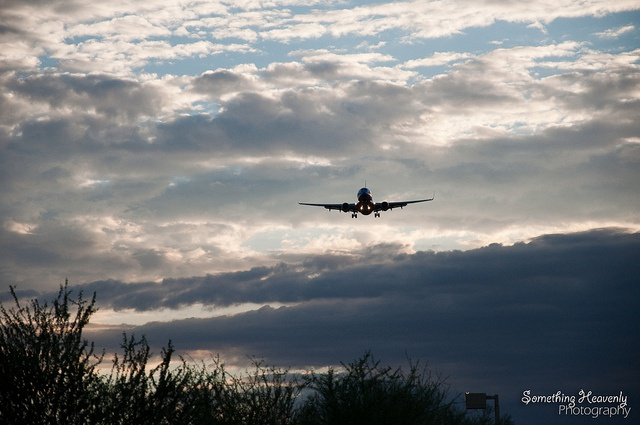Describe the objects in this image and their specific colors. I can see a airplane in gray, black, darkgray, and navy tones in this image. 